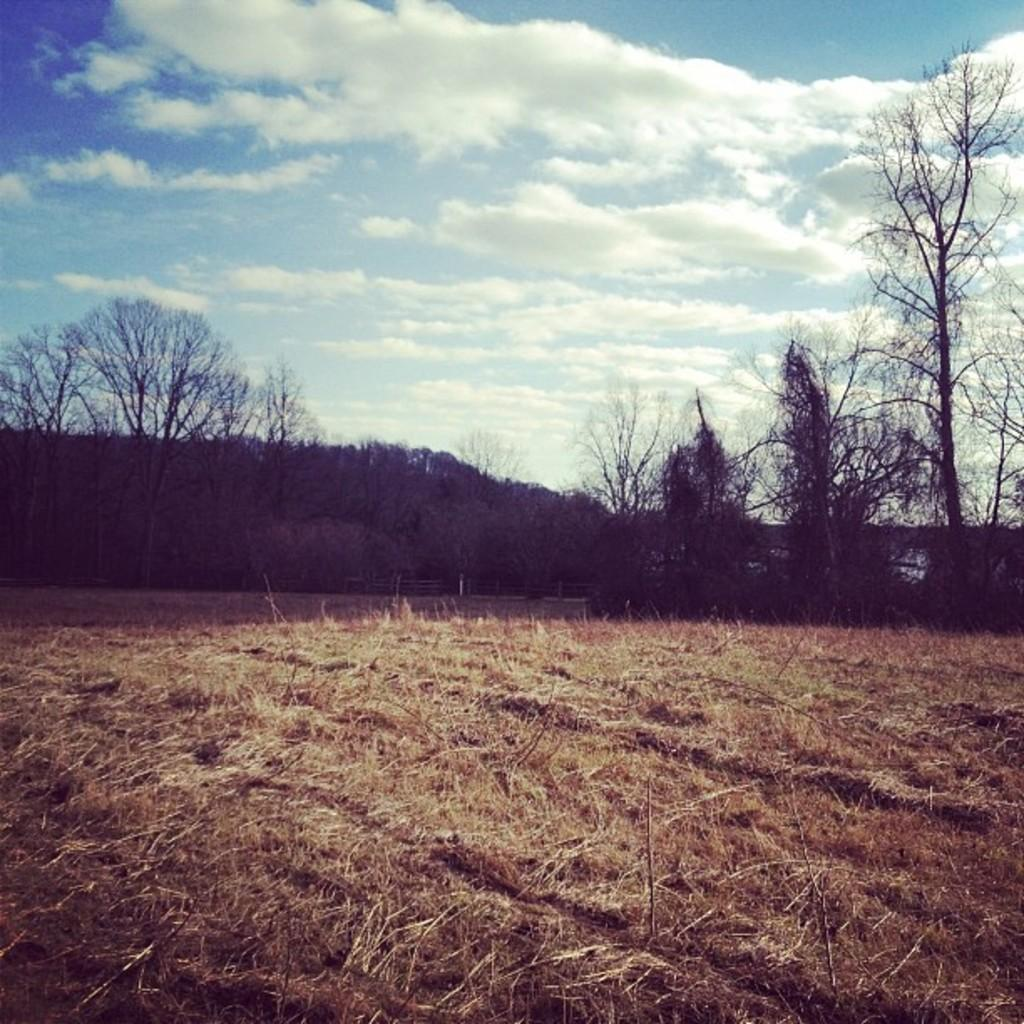What is the main feature in the middle of the image? There is a land in the middle of the image. What type of vegetation can be seen on the land? Dry grass is present on the land. What can be seen in the background of the image? There are trees in the background of the image. What is visible at the top of the image? The sky is visible at the top of the image. What can be observed in the sky? Clouds are present in the sky. How many grapes are being baked in the oven in the image? There is no oven or grapes present in the image. What are the boys doing in the image? There are no boys present in the image. 